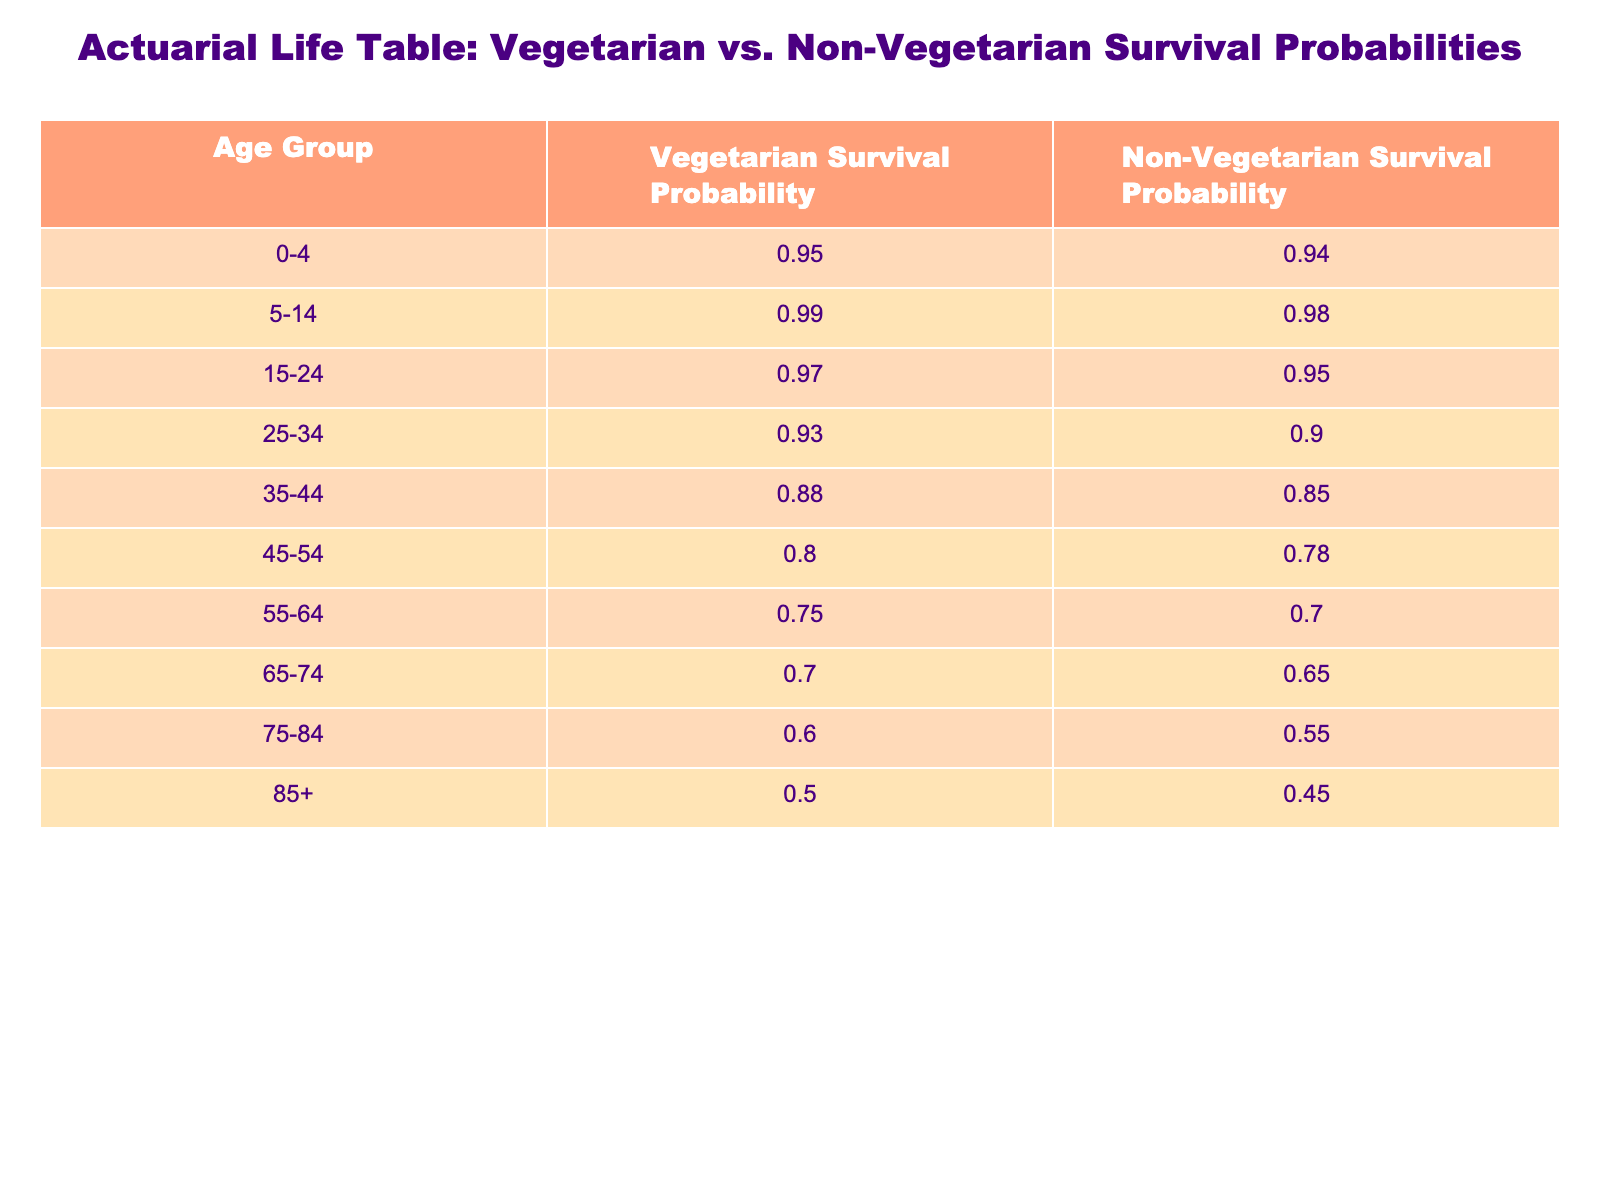What is the survival probability for the age group 25-34 for vegetarian food products? According to the table, the vegetarian survival probability for the age group 25-34 is 0.93.
Answer: 0.93 What is the survival probability for the age group 55-64 for non-vegetarian food products? The table indicates that the survival probability for non-vegetarian food products in the age group 55-64 is 0.70.
Answer: 0.70 Which age group has the highest survival probability for vegetarian food products? The highest survival probability for vegetarian food products is found in the age group 5-14, with a probability of 0.99.
Answer: 5-14 What is the difference in survival probability between vegetarian and non-vegetarian food products in the age group 75-84? For the age group 75-84, the vegetarian survival probability is 0.60 and the non-vegetarian is 0.55. The difference is 0.60 - 0.55 = 0.05.
Answer: 0.05 Is the survival probability for non-vegetarian food products lower for all age groups compared to vegetarian food products? Yes, the data shows that the survival probability for non-vegetarian food products is lower than for vegetarian products across all age groups listed in the table.
Answer: Yes What is the average survival probability for vegetarian food products across all age groups? To calculate the average, sum the survival probabilities: 0.95 + 0.99 + 0.97 + 0.93 + 0.88 + 0.80 + 0.75 + 0.70 + 0.60 + 0.50 = 8.67. There are 10 age groups, so the average is 8.67 / 10 = 0.867.
Answer: 0.867 In which age group does the survival probability for vegetarian food products drop below 0.75? The table shows that the survival probability for vegetarian food products drops below 0.75 starting from the age group 55-64, where it is 0.75, continuing to decrease in the next age group.
Answer: 55-64 What is the survival probability for ages 85 and above for non-vegetarian food products? The survival probability for ages 85 and above for non-vegetarian food products is indicated as 0.45 in the table.
Answer: 0.45 What is the median survival probability for non-vegetarian food products in the age groups? To find the median, we list the survival probabilities: 0.94, 0.98, 0.95, 0.90, 0.85, 0.78, 0.70, 0.65, 0.55, 0.45. Arranging these values gives us: 0.45, 0.55, 0.65, 0.70, 0.78, 0.80, 0.85, 0.90, 0.95, 0.98, the median (middle value) of the sorted list is (0.78 + 0.80)/2 = 0.79.
Answer: 0.79 